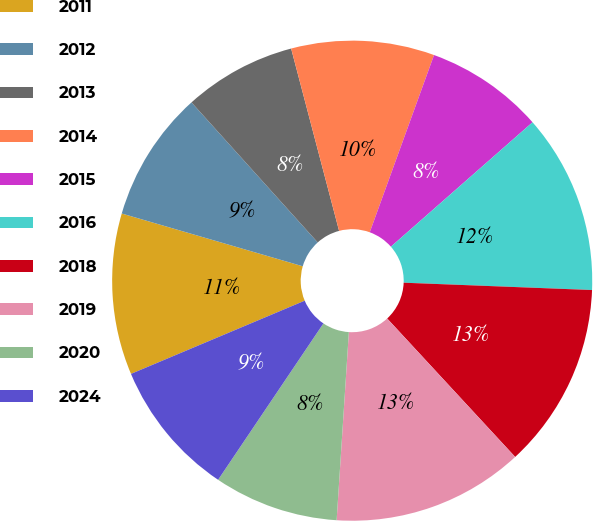Convert chart to OTSL. <chart><loc_0><loc_0><loc_500><loc_500><pie_chart><fcel>2011<fcel>2012<fcel>2013<fcel>2014<fcel>2015<fcel>2016<fcel>2018<fcel>2019<fcel>2020<fcel>2024<nl><fcel>10.86%<fcel>8.81%<fcel>7.58%<fcel>9.63%<fcel>7.99%<fcel>12.09%<fcel>12.5%<fcel>12.91%<fcel>8.4%<fcel>9.22%<nl></chart> 